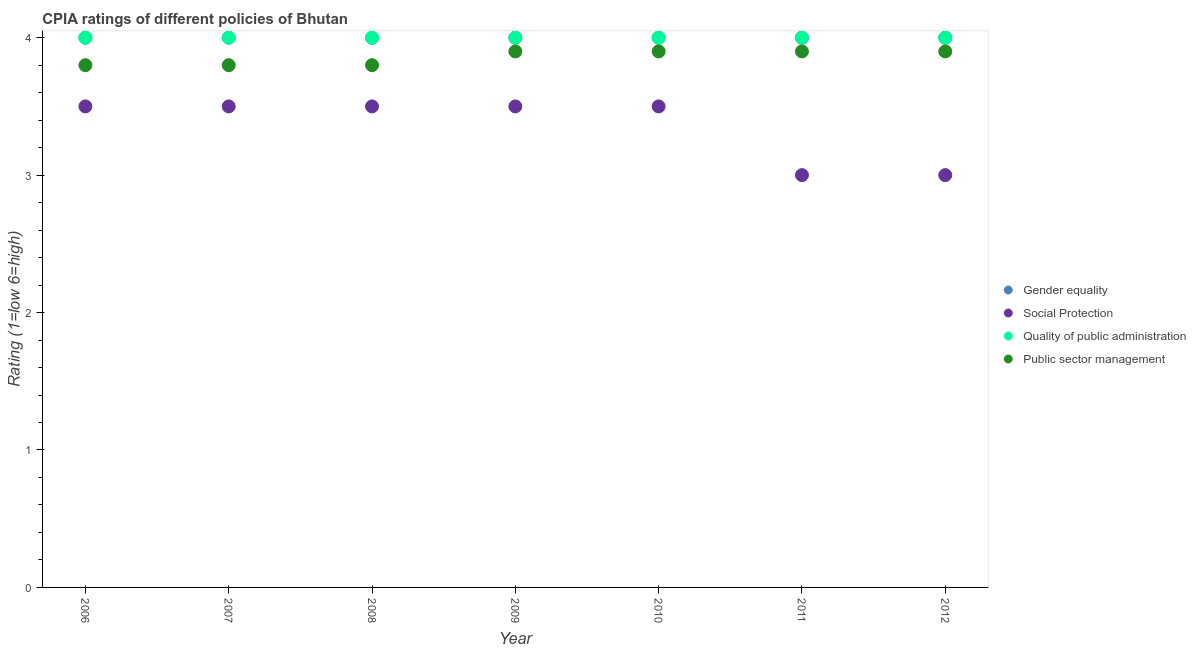Across all years, what is the maximum cpia rating of gender equality?
Ensure brevity in your answer.  4. Across all years, what is the minimum cpia rating of quality of public administration?
Your answer should be compact. 4. In which year was the cpia rating of public sector management minimum?
Provide a succinct answer. 2006. What is the total cpia rating of public sector management in the graph?
Give a very brief answer. 27. What is the difference between the cpia rating of social protection in 2007 and the cpia rating of public sector management in 2010?
Offer a terse response. -0.4. What is the average cpia rating of social protection per year?
Offer a terse response. 3.36. In how many years, is the cpia rating of social protection greater than 1.2?
Offer a terse response. 7. What is the ratio of the cpia rating of gender equality in 2007 to that in 2008?
Your answer should be very brief. 1. What is the difference between the highest and the second highest cpia rating of quality of public administration?
Offer a terse response. 0. What is the difference between the highest and the lowest cpia rating of gender equality?
Keep it short and to the point. 0. Is the sum of the cpia rating of public sector management in 2011 and 2012 greater than the maximum cpia rating of quality of public administration across all years?
Keep it short and to the point. Yes. Is it the case that in every year, the sum of the cpia rating of social protection and cpia rating of public sector management is greater than the sum of cpia rating of quality of public administration and cpia rating of gender equality?
Keep it short and to the point. No. Is it the case that in every year, the sum of the cpia rating of gender equality and cpia rating of social protection is greater than the cpia rating of quality of public administration?
Your answer should be compact. Yes. Does the cpia rating of quality of public administration monotonically increase over the years?
Your response must be concise. No. Is the cpia rating of social protection strictly greater than the cpia rating of public sector management over the years?
Offer a very short reply. No. Is the cpia rating of public sector management strictly less than the cpia rating of quality of public administration over the years?
Provide a succinct answer. Yes. How many dotlines are there?
Your response must be concise. 4. What is the difference between two consecutive major ticks on the Y-axis?
Your answer should be very brief. 1. Does the graph contain any zero values?
Provide a short and direct response. No. Where does the legend appear in the graph?
Ensure brevity in your answer.  Center right. How are the legend labels stacked?
Give a very brief answer. Vertical. What is the title of the graph?
Your response must be concise. CPIA ratings of different policies of Bhutan. Does "Quality of logistic services" appear as one of the legend labels in the graph?
Your answer should be very brief. No. What is the label or title of the Y-axis?
Your answer should be compact. Rating (1=low 6=high). What is the Rating (1=low 6=high) of Social Protection in 2006?
Offer a very short reply. 3.5. What is the Rating (1=low 6=high) in Quality of public administration in 2006?
Give a very brief answer. 4. What is the Rating (1=low 6=high) in Public sector management in 2006?
Offer a very short reply. 3.8. What is the Rating (1=low 6=high) in Social Protection in 2007?
Your response must be concise. 3.5. What is the Rating (1=low 6=high) in Quality of public administration in 2007?
Keep it short and to the point. 4. What is the Rating (1=low 6=high) of Public sector management in 2007?
Provide a short and direct response. 3.8. What is the Rating (1=low 6=high) in Gender equality in 2008?
Make the answer very short. 4. What is the Rating (1=low 6=high) of Gender equality in 2009?
Offer a very short reply. 4. What is the Rating (1=low 6=high) in Gender equality in 2010?
Give a very brief answer. 4. What is the Rating (1=low 6=high) in Social Protection in 2010?
Your answer should be compact. 3.5. What is the Rating (1=low 6=high) in Quality of public administration in 2010?
Your answer should be compact. 4. What is the Rating (1=low 6=high) of Public sector management in 2010?
Provide a short and direct response. 3.9. What is the Rating (1=low 6=high) of Gender equality in 2011?
Offer a terse response. 4. What is the Rating (1=low 6=high) in Social Protection in 2012?
Provide a short and direct response. 3. What is the Rating (1=low 6=high) in Quality of public administration in 2012?
Ensure brevity in your answer.  4. Across all years, what is the maximum Rating (1=low 6=high) of Gender equality?
Your response must be concise. 4. Across all years, what is the minimum Rating (1=low 6=high) of Gender equality?
Your response must be concise. 4. Across all years, what is the minimum Rating (1=low 6=high) in Social Protection?
Make the answer very short. 3. What is the total Rating (1=low 6=high) of Gender equality in the graph?
Provide a short and direct response. 28. What is the total Rating (1=low 6=high) in Quality of public administration in the graph?
Your answer should be compact. 28. What is the difference between the Rating (1=low 6=high) of Gender equality in 2006 and that in 2007?
Give a very brief answer. 0. What is the difference between the Rating (1=low 6=high) of Social Protection in 2006 and that in 2007?
Your response must be concise. 0. What is the difference between the Rating (1=low 6=high) of Quality of public administration in 2006 and that in 2007?
Your answer should be very brief. 0. What is the difference between the Rating (1=low 6=high) in Social Protection in 2006 and that in 2008?
Your answer should be compact. 0. What is the difference between the Rating (1=low 6=high) in Public sector management in 2006 and that in 2008?
Ensure brevity in your answer.  0. What is the difference between the Rating (1=low 6=high) of Social Protection in 2006 and that in 2009?
Keep it short and to the point. 0. What is the difference between the Rating (1=low 6=high) in Quality of public administration in 2006 and that in 2009?
Your response must be concise. 0. What is the difference between the Rating (1=low 6=high) in Gender equality in 2006 and that in 2010?
Your answer should be compact. 0. What is the difference between the Rating (1=low 6=high) of Public sector management in 2006 and that in 2010?
Give a very brief answer. -0.1. What is the difference between the Rating (1=low 6=high) of Social Protection in 2006 and that in 2012?
Provide a short and direct response. 0.5. What is the difference between the Rating (1=low 6=high) in Public sector management in 2007 and that in 2008?
Your response must be concise. 0. What is the difference between the Rating (1=low 6=high) of Gender equality in 2007 and that in 2009?
Give a very brief answer. 0. What is the difference between the Rating (1=low 6=high) of Quality of public administration in 2007 and that in 2009?
Make the answer very short. 0. What is the difference between the Rating (1=low 6=high) of Public sector management in 2007 and that in 2009?
Give a very brief answer. -0.1. What is the difference between the Rating (1=low 6=high) in Social Protection in 2007 and that in 2010?
Offer a very short reply. 0. What is the difference between the Rating (1=low 6=high) of Public sector management in 2007 and that in 2010?
Make the answer very short. -0.1. What is the difference between the Rating (1=low 6=high) in Social Protection in 2007 and that in 2011?
Keep it short and to the point. 0.5. What is the difference between the Rating (1=low 6=high) in Public sector management in 2007 and that in 2011?
Give a very brief answer. -0.1. What is the difference between the Rating (1=low 6=high) in Social Protection in 2007 and that in 2012?
Your response must be concise. 0.5. What is the difference between the Rating (1=low 6=high) in Social Protection in 2008 and that in 2009?
Your answer should be compact. 0. What is the difference between the Rating (1=low 6=high) of Quality of public administration in 2008 and that in 2009?
Provide a succinct answer. 0. What is the difference between the Rating (1=low 6=high) of Public sector management in 2008 and that in 2009?
Keep it short and to the point. -0.1. What is the difference between the Rating (1=low 6=high) of Quality of public administration in 2008 and that in 2010?
Keep it short and to the point. 0. What is the difference between the Rating (1=low 6=high) in Public sector management in 2008 and that in 2010?
Offer a very short reply. -0.1. What is the difference between the Rating (1=low 6=high) in Quality of public administration in 2008 and that in 2011?
Give a very brief answer. 0. What is the difference between the Rating (1=low 6=high) of Public sector management in 2008 and that in 2011?
Offer a very short reply. -0.1. What is the difference between the Rating (1=low 6=high) of Gender equality in 2008 and that in 2012?
Provide a short and direct response. 0. What is the difference between the Rating (1=low 6=high) in Public sector management in 2008 and that in 2012?
Make the answer very short. -0.1. What is the difference between the Rating (1=low 6=high) of Gender equality in 2009 and that in 2010?
Make the answer very short. 0. What is the difference between the Rating (1=low 6=high) in Quality of public administration in 2009 and that in 2010?
Make the answer very short. 0. What is the difference between the Rating (1=low 6=high) of Public sector management in 2009 and that in 2010?
Provide a short and direct response. 0. What is the difference between the Rating (1=low 6=high) of Social Protection in 2009 and that in 2011?
Give a very brief answer. 0.5. What is the difference between the Rating (1=low 6=high) of Public sector management in 2009 and that in 2011?
Provide a succinct answer. 0. What is the difference between the Rating (1=low 6=high) of Gender equality in 2009 and that in 2012?
Provide a short and direct response. 0. What is the difference between the Rating (1=low 6=high) in Quality of public administration in 2009 and that in 2012?
Your answer should be compact. 0. What is the difference between the Rating (1=low 6=high) of Social Protection in 2010 and that in 2011?
Your answer should be compact. 0.5. What is the difference between the Rating (1=low 6=high) of Gender equality in 2010 and that in 2012?
Provide a succinct answer. 0. What is the difference between the Rating (1=low 6=high) of Public sector management in 2010 and that in 2012?
Your answer should be compact. 0. What is the difference between the Rating (1=low 6=high) in Gender equality in 2011 and that in 2012?
Provide a short and direct response. 0. What is the difference between the Rating (1=low 6=high) in Social Protection in 2011 and that in 2012?
Your answer should be compact. 0. What is the difference between the Rating (1=low 6=high) of Quality of public administration in 2011 and that in 2012?
Provide a short and direct response. 0. What is the difference between the Rating (1=low 6=high) in Gender equality in 2006 and the Rating (1=low 6=high) in Social Protection in 2007?
Your answer should be very brief. 0.5. What is the difference between the Rating (1=low 6=high) of Gender equality in 2006 and the Rating (1=low 6=high) of Public sector management in 2007?
Offer a very short reply. 0.2. What is the difference between the Rating (1=low 6=high) of Social Protection in 2006 and the Rating (1=low 6=high) of Public sector management in 2007?
Your answer should be compact. -0.3. What is the difference between the Rating (1=low 6=high) in Quality of public administration in 2006 and the Rating (1=low 6=high) in Public sector management in 2007?
Make the answer very short. 0.2. What is the difference between the Rating (1=low 6=high) in Gender equality in 2006 and the Rating (1=low 6=high) in Social Protection in 2008?
Ensure brevity in your answer.  0.5. What is the difference between the Rating (1=low 6=high) of Gender equality in 2006 and the Rating (1=low 6=high) of Quality of public administration in 2008?
Ensure brevity in your answer.  0. What is the difference between the Rating (1=low 6=high) of Social Protection in 2006 and the Rating (1=low 6=high) of Public sector management in 2008?
Your response must be concise. -0.3. What is the difference between the Rating (1=low 6=high) of Gender equality in 2006 and the Rating (1=low 6=high) of Public sector management in 2009?
Ensure brevity in your answer.  0.1. What is the difference between the Rating (1=low 6=high) in Quality of public administration in 2006 and the Rating (1=low 6=high) in Public sector management in 2009?
Offer a terse response. 0.1. What is the difference between the Rating (1=low 6=high) in Gender equality in 2006 and the Rating (1=low 6=high) in Social Protection in 2010?
Give a very brief answer. 0.5. What is the difference between the Rating (1=low 6=high) of Gender equality in 2006 and the Rating (1=low 6=high) of Quality of public administration in 2010?
Provide a short and direct response. 0. What is the difference between the Rating (1=low 6=high) of Social Protection in 2006 and the Rating (1=low 6=high) of Public sector management in 2010?
Your answer should be very brief. -0.4. What is the difference between the Rating (1=low 6=high) in Quality of public administration in 2006 and the Rating (1=low 6=high) in Public sector management in 2010?
Provide a succinct answer. 0.1. What is the difference between the Rating (1=low 6=high) of Gender equality in 2006 and the Rating (1=low 6=high) of Public sector management in 2011?
Keep it short and to the point. 0.1. What is the difference between the Rating (1=low 6=high) in Social Protection in 2006 and the Rating (1=low 6=high) in Public sector management in 2011?
Give a very brief answer. -0.4. What is the difference between the Rating (1=low 6=high) in Quality of public administration in 2006 and the Rating (1=low 6=high) in Public sector management in 2011?
Your answer should be very brief. 0.1. What is the difference between the Rating (1=low 6=high) in Gender equality in 2006 and the Rating (1=low 6=high) in Social Protection in 2012?
Provide a short and direct response. 1. What is the difference between the Rating (1=low 6=high) in Gender equality in 2006 and the Rating (1=low 6=high) in Public sector management in 2012?
Ensure brevity in your answer.  0.1. What is the difference between the Rating (1=low 6=high) of Gender equality in 2007 and the Rating (1=low 6=high) of Social Protection in 2008?
Keep it short and to the point. 0.5. What is the difference between the Rating (1=low 6=high) of Gender equality in 2007 and the Rating (1=low 6=high) of Public sector management in 2008?
Give a very brief answer. 0.2. What is the difference between the Rating (1=low 6=high) in Social Protection in 2007 and the Rating (1=low 6=high) in Quality of public administration in 2008?
Provide a short and direct response. -0.5. What is the difference between the Rating (1=low 6=high) in Gender equality in 2007 and the Rating (1=low 6=high) in Quality of public administration in 2009?
Your answer should be very brief. 0. What is the difference between the Rating (1=low 6=high) of Gender equality in 2007 and the Rating (1=low 6=high) of Public sector management in 2009?
Your response must be concise. 0.1. What is the difference between the Rating (1=low 6=high) of Social Protection in 2007 and the Rating (1=low 6=high) of Public sector management in 2009?
Your answer should be compact. -0.4. What is the difference between the Rating (1=low 6=high) of Quality of public administration in 2007 and the Rating (1=low 6=high) of Public sector management in 2009?
Give a very brief answer. 0.1. What is the difference between the Rating (1=low 6=high) of Social Protection in 2007 and the Rating (1=low 6=high) of Quality of public administration in 2010?
Your response must be concise. -0.5. What is the difference between the Rating (1=low 6=high) of Gender equality in 2007 and the Rating (1=low 6=high) of Social Protection in 2011?
Your response must be concise. 1. What is the difference between the Rating (1=low 6=high) in Gender equality in 2007 and the Rating (1=low 6=high) in Quality of public administration in 2011?
Your response must be concise. 0. What is the difference between the Rating (1=low 6=high) in Social Protection in 2007 and the Rating (1=low 6=high) in Public sector management in 2011?
Keep it short and to the point. -0.4. What is the difference between the Rating (1=low 6=high) of Gender equality in 2007 and the Rating (1=low 6=high) of Quality of public administration in 2012?
Make the answer very short. 0. What is the difference between the Rating (1=low 6=high) in Gender equality in 2007 and the Rating (1=low 6=high) in Public sector management in 2012?
Give a very brief answer. 0.1. What is the difference between the Rating (1=low 6=high) of Social Protection in 2007 and the Rating (1=low 6=high) of Quality of public administration in 2012?
Provide a succinct answer. -0.5. What is the difference between the Rating (1=low 6=high) in Gender equality in 2008 and the Rating (1=low 6=high) in Social Protection in 2009?
Provide a short and direct response. 0.5. What is the difference between the Rating (1=low 6=high) in Gender equality in 2008 and the Rating (1=low 6=high) in Quality of public administration in 2009?
Keep it short and to the point. 0. What is the difference between the Rating (1=low 6=high) of Gender equality in 2008 and the Rating (1=low 6=high) of Public sector management in 2009?
Offer a very short reply. 0.1. What is the difference between the Rating (1=low 6=high) of Gender equality in 2008 and the Rating (1=low 6=high) of Social Protection in 2010?
Your response must be concise. 0.5. What is the difference between the Rating (1=low 6=high) of Gender equality in 2008 and the Rating (1=low 6=high) of Public sector management in 2010?
Your answer should be compact. 0.1. What is the difference between the Rating (1=low 6=high) of Social Protection in 2008 and the Rating (1=low 6=high) of Public sector management in 2010?
Offer a very short reply. -0.4. What is the difference between the Rating (1=low 6=high) in Quality of public administration in 2008 and the Rating (1=low 6=high) in Public sector management in 2010?
Your response must be concise. 0.1. What is the difference between the Rating (1=low 6=high) of Gender equality in 2008 and the Rating (1=low 6=high) of Social Protection in 2011?
Your answer should be compact. 1. What is the difference between the Rating (1=low 6=high) in Quality of public administration in 2008 and the Rating (1=low 6=high) in Public sector management in 2011?
Give a very brief answer. 0.1. What is the difference between the Rating (1=low 6=high) of Gender equality in 2008 and the Rating (1=low 6=high) of Public sector management in 2012?
Offer a terse response. 0.1. What is the difference between the Rating (1=low 6=high) in Social Protection in 2008 and the Rating (1=low 6=high) in Quality of public administration in 2012?
Provide a short and direct response. -0.5. What is the difference between the Rating (1=low 6=high) in Social Protection in 2008 and the Rating (1=low 6=high) in Public sector management in 2012?
Offer a very short reply. -0.4. What is the difference between the Rating (1=low 6=high) in Quality of public administration in 2008 and the Rating (1=low 6=high) in Public sector management in 2012?
Your answer should be compact. 0.1. What is the difference between the Rating (1=low 6=high) of Gender equality in 2009 and the Rating (1=low 6=high) of Quality of public administration in 2010?
Provide a succinct answer. 0. What is the difference between the Rating (1=low 6=high) of Gender equality in 2009 and the Rating (1=low 6=high) of Public sector management in 2010?
Ensure brevity in your answer.  0.1. What is the difference between the Rating (1=low 6=high) in Social Protection in 2009 and the Rating (1=low 6=high) in Quality of public administration in 2010?
Keep it short and to the point. -0.5. What is the difference between the Rating (1=low 6=high) of Quality of public administration in 2009 and the Rating (1=low 6=high) of Public sector management in 2010?
Offer a terse response. 0.1. What is the difference between the Rating (1=low 6=high) of Gender equality in 2009 and the Rating (1=low 6=high) of Social Protection in 2011?
Offer a very short reply. 1. What is the difference between the Rating (1=low 6=high) in Gender equality in 2009 and the Rating (1=low 6=high) in Quality of public administration in 2011?
Your answer should be compact. 0. What is the difference between the Rating (1=low 6=high) of Gender equality in 2009 and the Rating (1=low 6=high) of Public sector management in 2011?
Give a very brief answer. 0.1. What is the difference between the Rating (1=low 6=high) in Social Protection in 2009 and the Rating (1=low 6=high) in Public sector management in 2011?
Offer a terse response. -0.4. What is the difference between the Rating (1=low 6=high) in Quality of public administration in 2009 and the Rating (1=low 6=high) in Public sector management in 2011?
Make the answer very short. 0.1. What is the difference between the Rating (1=low 6=high) of Gender equality in 2009 and the Rating (1=low 6=high) of Social Protection in 2012?
Provide a succinct answer. 1. What is the difference between the Rating (1=low 6=high) in Gender equality in 2009 and the Rating (1=low 6=high) in Public sector management in 2012?
Give a very brief answer. 0.1. What is the difference between the Rating (1=low 6=high) of Social Protection in 2009 and the Rating (1=low 6=high) of Quality of public administration in 2012?
Provide a succinct answer. -0.5. What is the difference between the Rating (1=low 6=high) of Social Protection in 2009 and the Rating (1=low 6=high) of Public sector management in 2012?
Your answer should be compact. -0.4. What is the difference between the Rating (1=low 6=high) in Quality of public administration in 2009 and the Rating (1=low 6=high) in Public sector management in 2012?
Your answer should be compact. 0.1. What is the difference between the Rating (1=low 6=high) in Gender equality in 2010 and the Rating (1=low 6=high) in Social Protection in 2011?
Provide a short and direct response. 1. What is the difference between the Rating (1=low 6=high) in Gender equality in 2010 and the Rating (1=low 6=high) in Public sector management in 2011?
Your answer should be very brief. 0.1. What is the difference between the Rating (1=low 6=high) of Social Protection in 2010 and the Rating (1=low 6=high) of Public sector management in 2011?
Provide a short and direct response. -0.4. What is the difference between the Rating (1=low 6=high) in Quality of public administration in 2010 and the Rating (1=low 6=high) in Public sector management in 2011?
Provide a succinct answer. 0.1. What is the difference between the Rating (1=low 6=high) of Gender equality in 2010 and the Rating (1=low 6=high) of Public sector management in 2012?
Make the answer very short. 0.1. What is the difference between the Rating (1=low 6=high) of Social Protection in 2010 and the Rating (1=low 6=high) of Quality of public administration in 2012?
Provide a succinct answer. -0.5. What is the difference between the Rating (1=low 6=high) of Gender equality in 2011 and the Rating (1=low 6=high) of Social Protection in 2012?
Ensure brevity in your answer.  1. What is the difference between the Rating (1=low 6=high) in Gender equality in 2011 and the Rating (1=low 6=high) in Quality of public administration in 2012?
Ensure brevity in your answer.  0. What is the difference between the Rating (1=low 6=high) in Gender equality in 2011 and the Rating (1=low 6=high) in Public sector management in 2012?
Your response must be concise. 0.1. What is the difference between the Rating (1=low 6=high) of Social Protection in 2011 and the Rating (1=low 6=high) of Quality of public administration in 2012?
Your answer should be compact. -1. What is the average Rating (1=low 6=high) of Gender equality per year?
Ensure brevity in your answer.  4. What is the average Rating (1=low 6=high) in Social Protection per year?
Provide a short and direct response. 3.36. What is the average Rating (1=low 6=high) in Quality of public administration per year?
Provide a short and direct response. 4. What is the average Rating (1=low 6=high) in Public sector management per year?
Offer a terse response. 3.86. In the year 2006, what is the difference between the Rating (1=low 6=high) of Gender equality and Rating (1=low 6=high) of Quality of public administration?
Offer a very short reply. 0. In the year 2006, what is the difference between the Rating (1=low 6=high) in Quality of public administration and Rating (1=low 6=high) in Public sector management?
Your response must be concise. 0.2. In the year 2007, what is the difference between the Rating (1=low 6=high) in Social Protection and Rating (1=low 6=high) in Public sector management?
Keep it short and to the point. -0.3. In the year 2008, what is the difference between the Rating (1=low 6=high) in Social Protection and Rating (1=low 6=high) in Quality of public administration?
Offer a very short reply. -0.5. In the year 2008, what is the difference between the Rating (1=low 6=high) of Quality of public administration and Rating (1=low 6=high) of Public sector management?
Make the answer very short. 0.2. In the year 2009, what is the difference between the Rating (1=low 6=high) in Gender equality and Rating (1=low 6=high) in Social Protection?
Offer a very short reply. 0.5. In the year 2009, what is the difference between the Rating (1=low 6=high) of Gender equality and Rating (1=low 6=high) of Quality of public administration?
Provide a short and direct response. 0. In the year 2009, what is the difference between the Rating (1=low 6=high) in Gender equality and Rating (1=low 6=high) in Public sector management?
Provide a short and direct response. 0.1. In the year 2009, what is the difference between the Rating (1=low 6=high) of Social Protection and Rating (1=low 6=high) of Quality of public administration?
Offer a terse response. -0.5. In the year 2009, what is the difference between the Rating (1=low 6=high) of Quality of public administration and Rating (1=low 6=high) of Public sector management?
Give a very brief answer. 0.1. In the year 2010, what is the difference between the Rating (1=low 6=high) of Gender equality and Rating (1=low 6=high) of Social Protection?
Offer a terse response. 0.5. In the year 2010, what is the difference between the Rating (1=low 6=high) in Social Protection and Rating (1=low 6=high) in Public sector management?
Offer a terse response. -0.4. In the year 2011, what is the difference between the Rating (1=low 6=high) in Gender equality and Rating (1=low 6=high) in Social Protection?
Offer a terse response. 1. In the year 2011, what is the difference between the Rating (1=low 6=high) in Gender equality and Rating (1=low 6=high) in Public sector management?
Your answer should be compact. 0.1. In the year 2011, what is the difference between the Rating (1=low 6=high) of Social Protection and Rating (1=low 6=high) of Quality of public administration?
Your answer should be very brief. -1. In the year 2011, what is the difference between the Rating (1=low 6=high) in Social Protection and Rating (1=low 6=high) in Public sector management?
Make the answer very short. -0.9. In the year 2011, what is the difference between the Rating (1=low 6=high) in Quality of public administration and Rating (1=low 6=high) in Public sector management?
Your answer should be very brief. 0.1. In the year 2012, what is the difference between the Rating (1=low 6=high) of Gender equality and Rating (1=low 6=high) of Quality of public administration?
Ensure brevity in your answer.  0. In the year 2012, what is the difference between the Rating (1=low 6=high) of Gender equality and Rating (1=low 6=high) of Public sector management?
Offer a very short reply. 0.1. In the year 2012, what is the difference between the Rating (1=low 6=high) of Social Protection and Rating (1=low 6=high) of Quality of public administration?
Your response must be concise. -1. In the year 2012, what is the difference between the Rating (1=low 6=high) in Social Protection and Rating (1=low 6=high) in Public sector management?
Provide a short and direct response. -0.9. What is the ratio of the Rating (1=low 6=high) in Quality of public administration in 2006 to that in 2007?
Provide a succinct answer. 1. What is the ratio of the Rating (1=low 6=high) in Gender equality in 2006 to that in 2008?
Offer a very short reply. 1. What is the ratio of the Rating (1=low 6=high) in Quality of public administration in 2006 to that in 2008?
Offer a very short reply. 1. What is the ratio of the Rating (1=low 6=high) in Public sector management in 2006 to that in 2008?
Your answer should be compact. 1. What is the ratio of the Rating (1=low 6=high) in Social Protection in 2006 to that in 2009?
Offer a terse response. 1. What is the ratio of the Rating (1=low 6=high) in Public sector management in 2006 to that in 2009?
Provide a short and direct response. 0.97. What is the ratio of the Rating (1=low 6=high) in Gender equality in 2006 to that in 2010?
Your answer should be very brief. 1. What is the ratio of the Rating (1=low 6=high) in Public sector management in 2006 to that in 2010?
Your answer should be compact. 0.97. What is the ratio of the Rating (1=low 6=high) of Quality of public administration in 2006 to that in 2011?
Provide a succinct answer. 1. What is the ratio of the Rating (1=low 6=high) of Public sector management in 2006 to that in 2011?
Offer a very short reply. 0.97. What is the ratio of the Rating (1=low 6=high) of Gender equality in 2006 to that in 2012?
Provide a short and direct response. 1. What is the ratio of the Rating (1=low 6=high) in Quality of public administration in 2006 to that in 2012?
Keep it short and to the point. 1. What is the ratio of the Rating (1=low 6=high) of Public sector management in 2006 to that in 2012?
Your response must be concise. 0.97. What is the ratio of the Rating (1=low 6=high) of Gender equality in 2007 to that in 2008?
Your response must be concise. 1. What is the ratio of the Rating (1=low 6=high) of Social Protection in 2007 to that in 2008?
Provide a succinct answer. 1. What is the ratio of the Rating (1=low 6=high) of Public sector management in 2007 to that in 2008?
Your answer should be compact. 1. What is the ratio of the Rating (1=low 6=high) of Gender equality in 2007 to that in 2009?
Provide a short and direct response. 1. What is the ratio of the Rating (1=low 6=high) of Public sector management in 2007 to that in 2009?
Your answer should be very brief. 0.97. What is the ratio of the Rating (1=low 6=high) in Gender equality in 2007 to that in 2010?
Your answer should be compact. 1. What is the ratio of the Rating (1=low 6=high) of Social Protection in 2007 to that in 2010?
Provide a short and direct response. 1. What is the ratio of the Rating (1=low 6=high) in Public sector management in 2007 to that in 2010?
Make the answer very short. 0.97. What is the ratio of the Rating (1=low 6=high) of Gender equality in 2007 to that in 2011?
Your answer should be very brief. 1. What is the ratio of the Rating (1=low 6=high) of Quality of public administration in 2007 to that in 2011?
Offer a very short reply. 1. What is the ratio of the Rating (1=low 6=high) in Public sector management in 2007 to that in 2011?
Your answer should be compact. 0.97. What is the ratio of the Rating (1=low 6=high) of Public sector management in 2007 to that in 2012?
Ensure brevity in your answer.  0.97. What is the ratio of the Rating (1=low 6=high) in Quality of public administration in 2008 to that in 2009?
Your answer should be very brief. 1. What is the ratio of the Rating (1=low 6=high) in Public sector management in 2008 to that in 2009?
Keep it short and to the point. 0.97. What is the ratio of the Rating (1=low 6=high) of Gender equality in 2008 to that in 2010?
Give a very brief answer. 1. What is the ratio of the Rating (1=low 6=high) in Social Protection in 2008 to that in 2010?
Offer a very short reply. 1. What is the ratio of the Rating (1=low 6=high) in Public sector management in 2008 to that in 2010?
Provide a short and direct response. 0.97. What is the ratio of the Rating (1=low 6=high) in Gender equality in 2008 to that in 2011?
Make the answer very short. 1. What is the ratio of the Rating (1=low 6=high) of Public sector management in 2008 to that in 2011?
Ensure brevity in your answer.  0.97. What is the ratio of the Rating (1=low 6=high) in Quality of public administration in 2008 to that in 2012?
Make the answer very short. 1. What is the ratio of the Rating (1=low 6=high) of Public sector management in 2008 to that in 2012?
Your answer should be very brief. 0.97. What is the ratio of the Rating (1=low 6=high) in Quality of public administration in 2009 to that in 2010?
Give a very brief answer. 1. What is the ratio of the Rating (1=low 6=high) of Gender equality in 2009 to that in 2011?
Make the answer very short. 1. What is the ratio of the Rating (1=low 6=high) in Social Protection in 2009 to that in 2011?
Keep it short and to the point. 1.17. What is the ratio of the Rating (1=low 6=high) in Public sector management in 2009 to that in 2011?
Your response must be concise. 1. What is the ratio of the Rating (1=low 6=high) in Social Protection in 2009 to that in 2012?
Provide a succinct answer. 1.17. What is the ratio of the Rating (1=low 6=high) in Public sector management in 2009 to that in 2012?
Provide a succinct answer. 1. What is the ratio of the Rating (1=low 6=high) in Gender equality in 2010 to that in 2011?
Offer a very short reply. 1. What is the ratio of the Rating (1=low 6=high) of Social Protection in 2010 to that in 2011?
Ensure brevity in your answer.  1.17. What is the ratio of the Rating (1=low 6=high) in Quality of public administration in 2010 to that in 2011?
Offer a terse response. 1. What is the ratio of the Rating (1=low 6=high) of Public sector management in 2010 to that in 2011?
Make the answer very short. 1. What is the ratio of the Rating (1=low 6=high) in Gender equality in 2010 to that in 2012?
Your answer should be compact. 1. What is the ratio of the Rating (1=low 6=high) of Quality of public administration in 2010 to that in 2012?
Offer a terse response. 1. What is the ratio of the Rating (1=low 6=high) of Public sector management in 2010 to that in 2012?
Make the answer very short. 1. What is the ratio of the Rating (1=low 6=high) in Social Protection in 2011 to that in 2012?
Provide a short and direct response. 1. What is the ratio of the Rating (1=low 6=high) in Quality of public administration in 2011 to that in 2012?
Keep it short and to the point. 1. What is the ratio of the Rating (1=low 6=high) of Public sector management in 2011 to that in 2012?
Your response must be concise. 1. What is the difference between the highest and the second highest Rating (1=low 6=high) of Gender equality?
Make the answer very short. 0. What is the difference between the highest and the lowest Rating (1=low 6=high) of Gender equality?
Your answer should be very brief. 0. What is the difference between the highest and the lowest Rating (1=low 6=high) in Public sector management?
Ensure brevity in your answer.  0.1. 